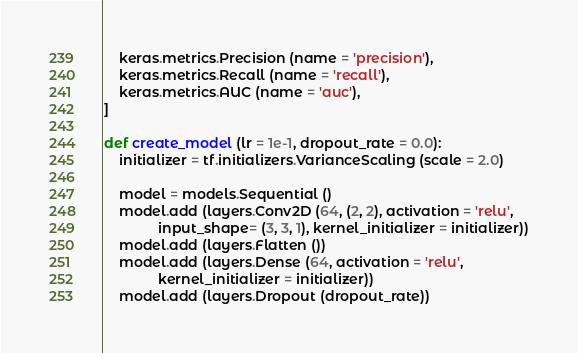<code> <loc_0><loc_0><loc_500><loc_500><_Python_>    keras.metrics.Precision (name = 'precision'),
    keras.metrics.Recall (name = 'recall'),
    keras.metrics.AUC (name = 'auc'),
]

def create_model (lr = 1e-1, dropout_rate = 0.0):
    initializer = tf.initializers.VarianceScaling (scale = 2.0)

    model = models.Sequential ()
    model.add (layers.Conv2D (64, (2, 2), activation = 'relu',
              input_shape= (3, 3, 1), kernel_initializer = initializer))
    model.add (layers.Flatten ())
    model.add (layers.Dense (64, activation = 'relu',
              kernel_initializer = initializer))
    model.add (layers.Dropout (dropout_rate))</code> 